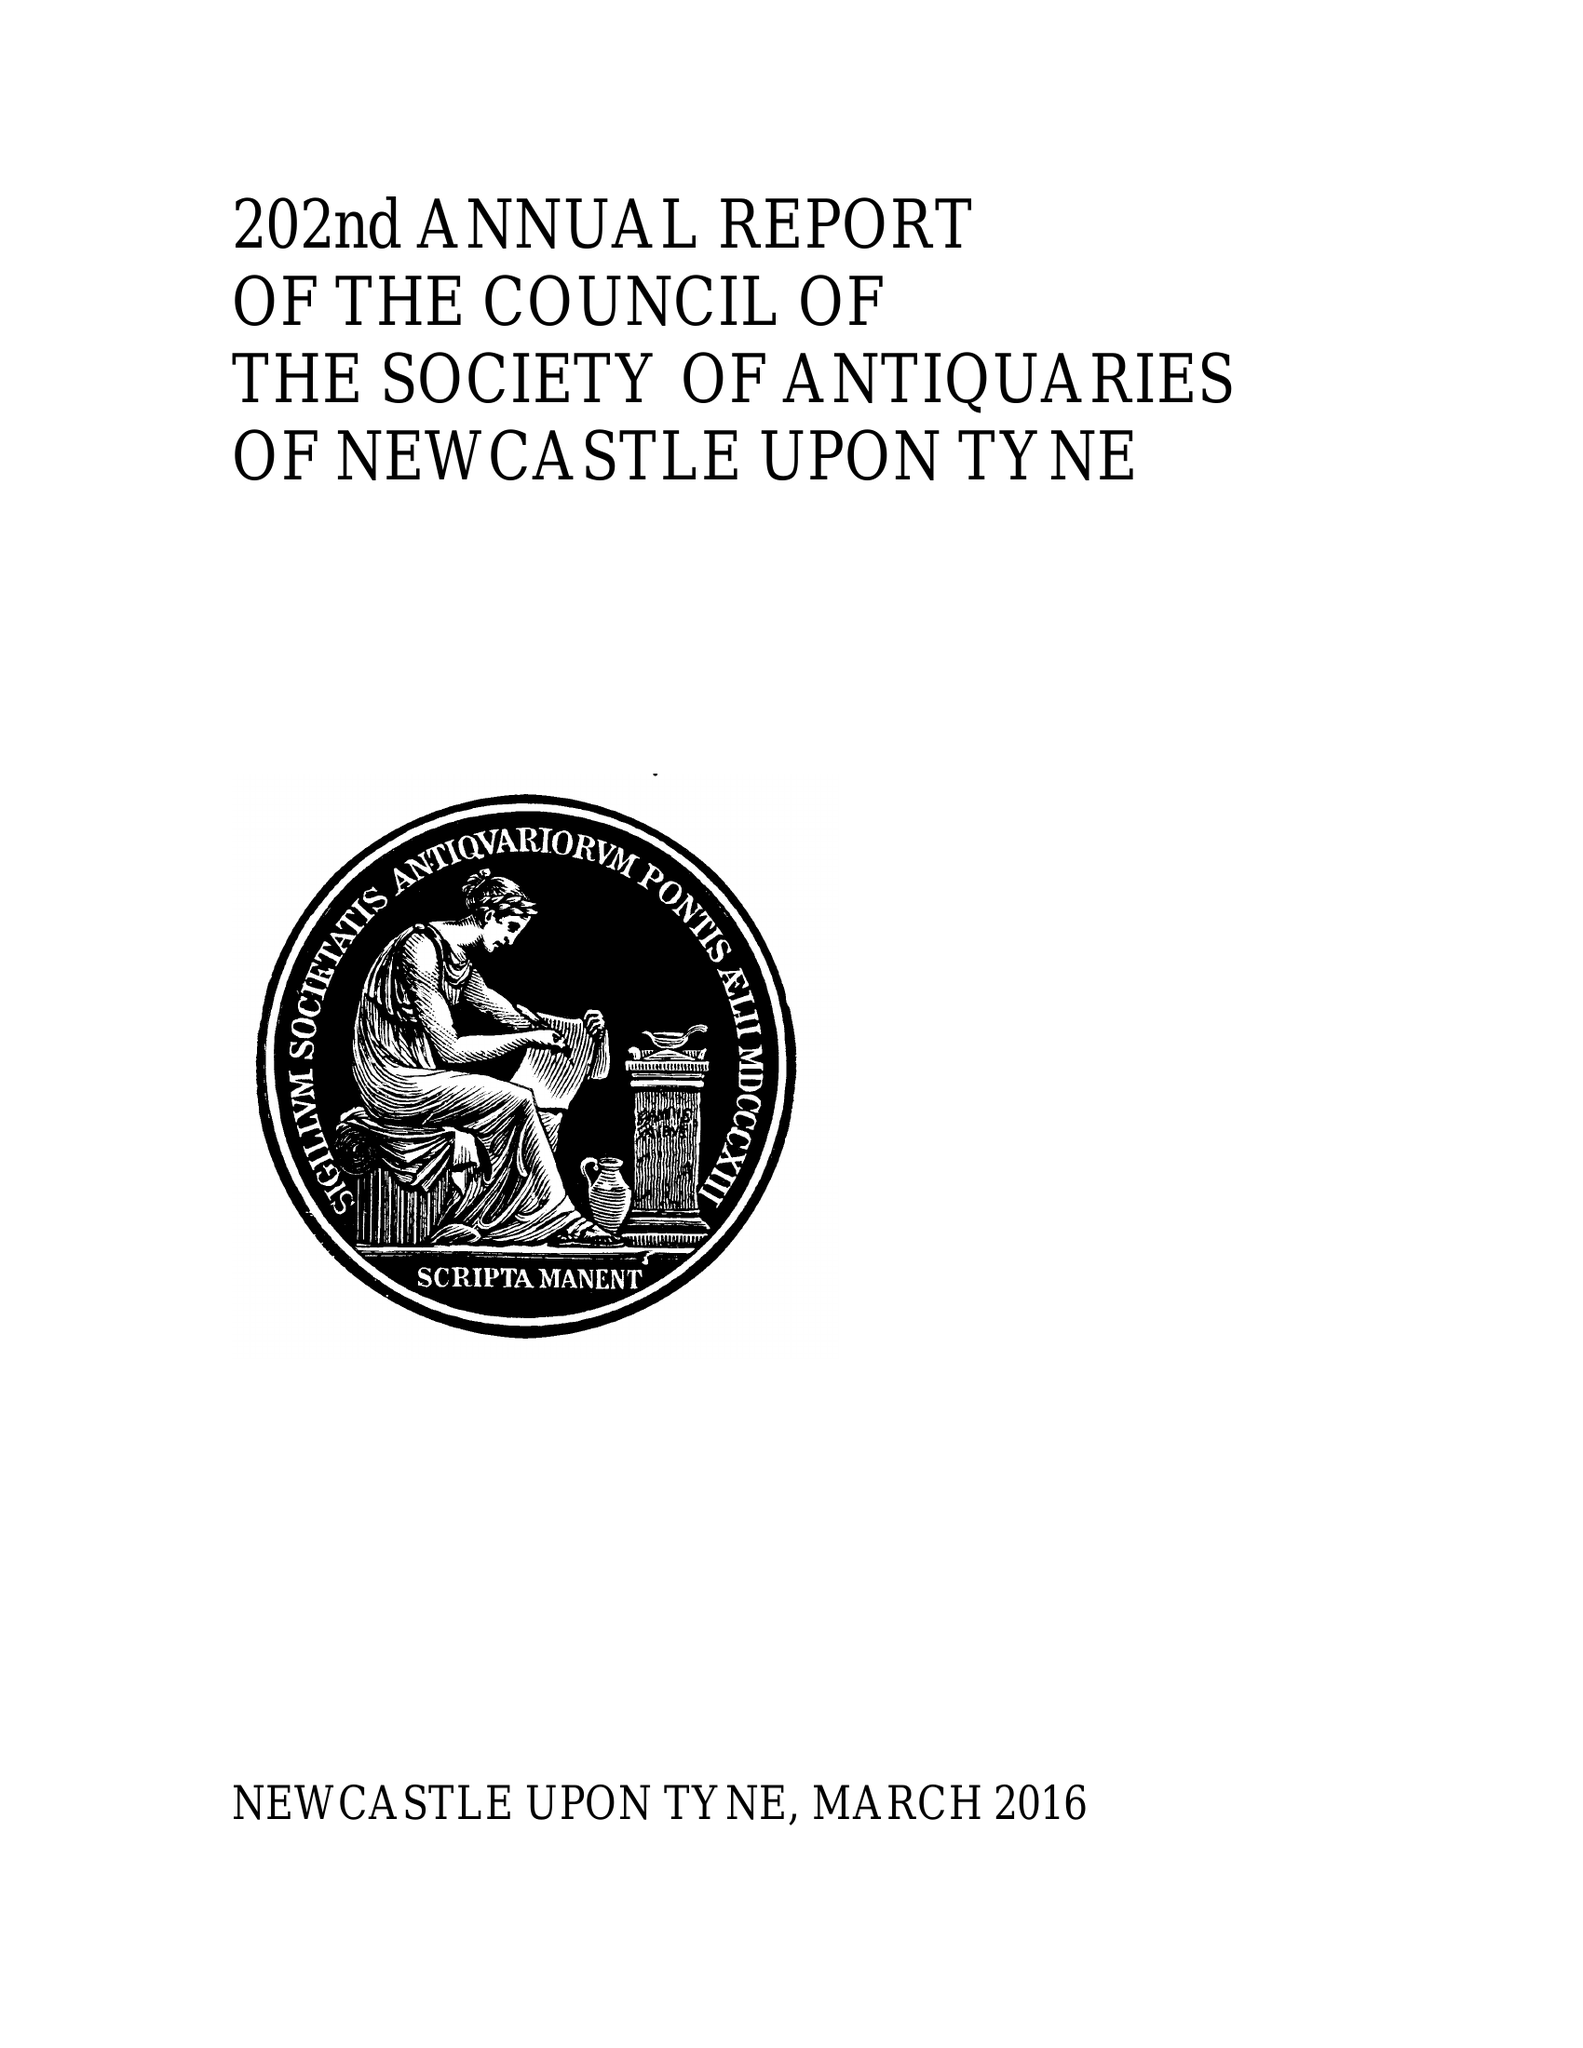What is the value for the charity_name?
Answer the question using a single word or phrase. The Society Of Antiquaries Of Newcastle Upon Tyne 